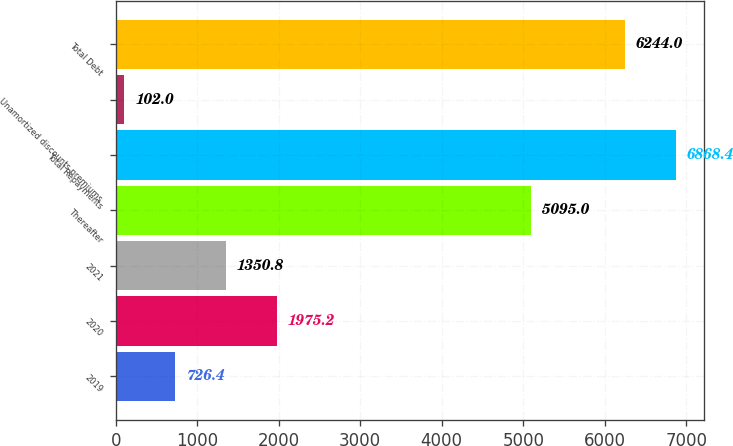<chart> <loc_0><loc_0><loc_500><loc_500><bar_chart><fcel>2019<fcel>2020<fcel>2021<fcel>Thereafter<fcel>Total Repayments<fcel>Unamortized discounts premiums<fcel>Total Debt<nl><fcel>726.4<fcel>1975.2<fcel>1350.8<fcel>5095<fcel>6868.4<fcel>102<fcel>6244<nl></chart> 